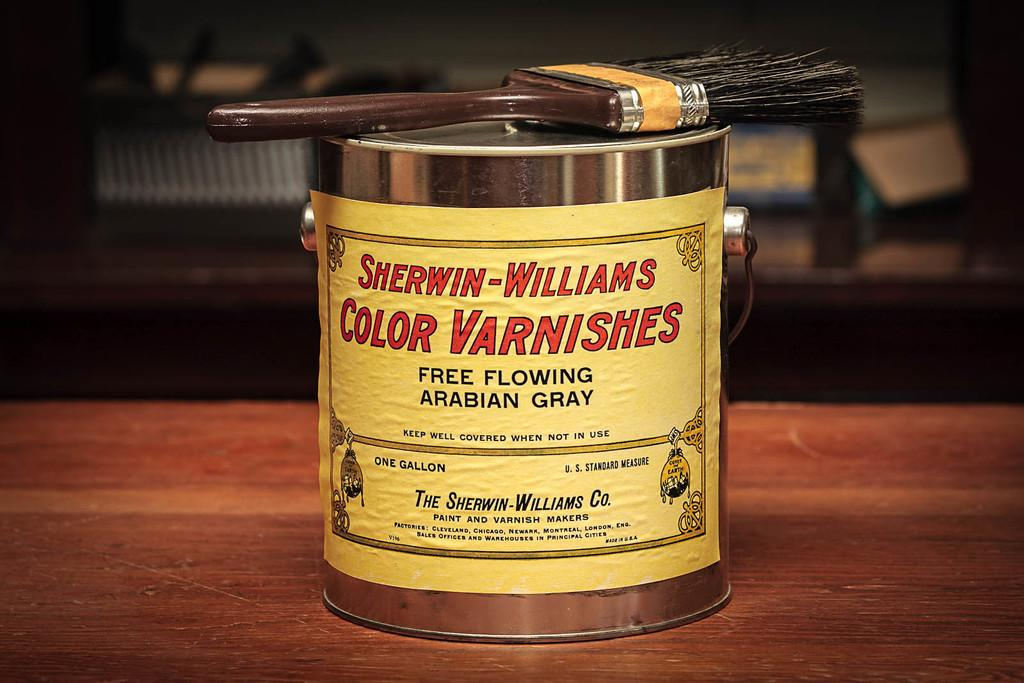<image>
Give a short and clear explanation of the subsequent image. a can that says sherwin williams on the front 